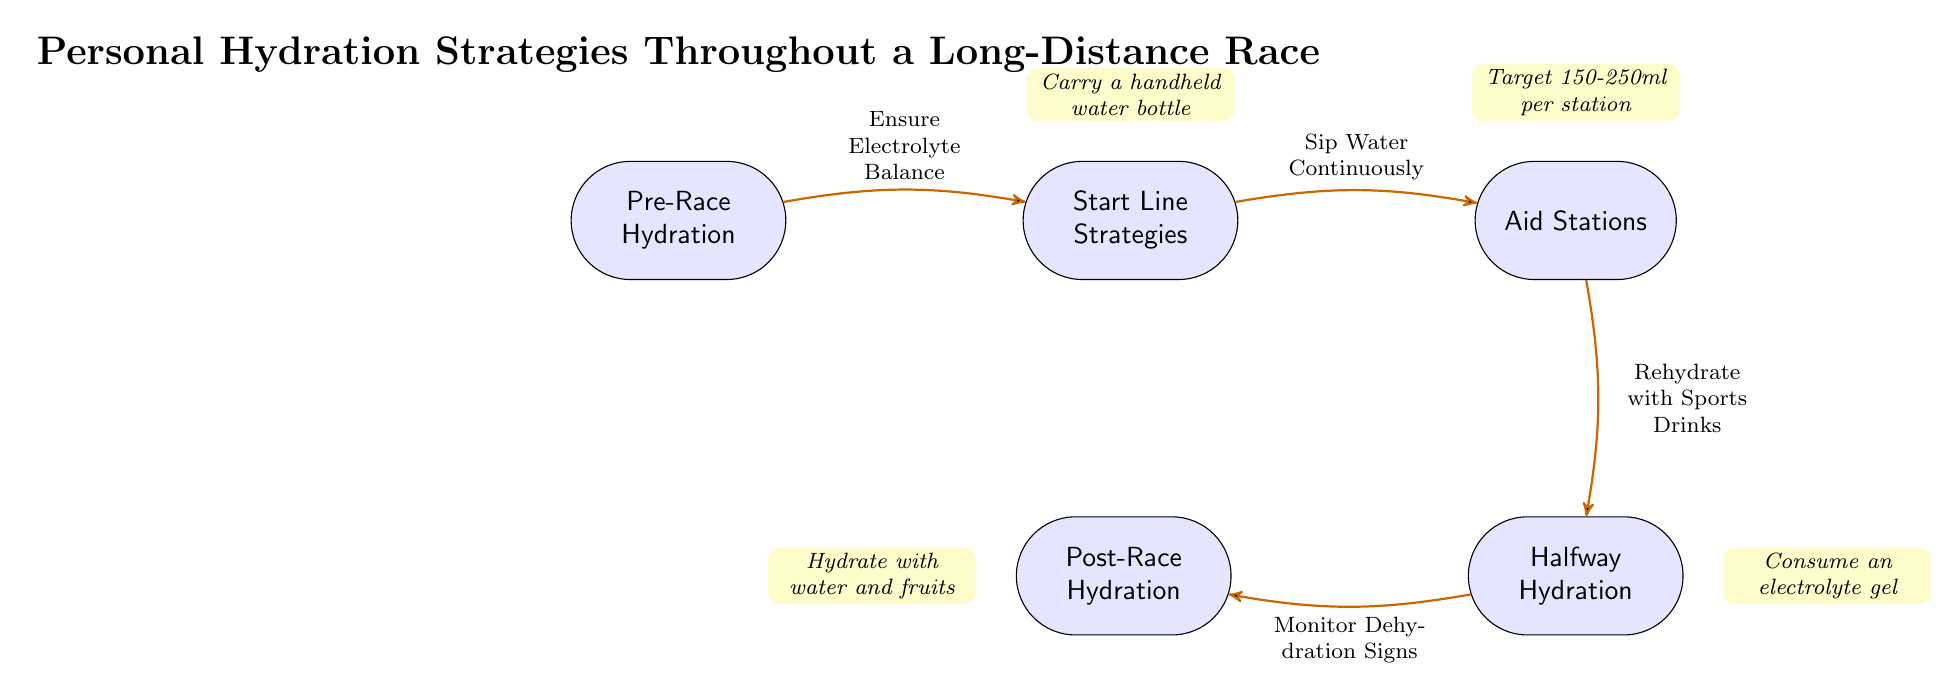What is the first node in the diagram? The first node, which is located at the top of the diagram, represents "Pre-Race Hydration".
Answer: Pre-Race Hydration How many nodes are present in the diagram? Counting all the nodes in the diagram, we find five distinct nodes: Pre-Race Hydration, Start Line Strategies, Aid Stations, Halfway Hydration, and Post-Race Hydration.
Answer: 5 What is the last hydration strategy shown before the finish line? Before reaching the finish line, the last hydration strategy depicted is "Monitor Dehydration Signs", which connects the Halfway Hydration node to the finish line.
Answer: Monitor Dehydration Signs What action is recommended at the start line? At the start line, the recommended action is to "Sip Water Continuously", guiding runners on hydration tactics at this phase.
Answer: Sip Water Continuously What should athletes consume at the halfway point? According to the diagram, runners are advised to "Consume an electrolyte gel" at the halfway point as part of their hydration strategy.
Answer: Consume an electrolyte gel What type of drink is suggested for rehydration at aid stations? The diagram advises that at aid stations, runners should "Rehydrate with Sports Drinks" to maintain hydration levels effectively.
Answer: Rehydrate with Sports Drinks What is noted for hydration strategy at the start line? The diagram notes to "Carry a handheld water bottle" as a practical suggestion for maintaining hydration during the race at this point.
Answer: Carry a handheld water bottle How much fluid should be targeted at each aid station? The diagram specifies a target of "150-250ml per station" for fluid intake at the aid stations, helping runners manage their hydration.
Answer: 150-250ml per station What is the final hydration strategy listed in the diagram? The final strategy listed in the diagram for post-race is "Hydrate with water and fruits", emphasizing recovery after completing the race.
Answer: Hydrate with water and fruits 